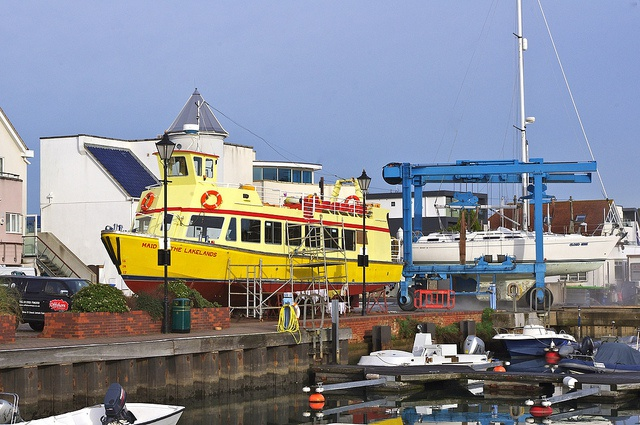Describe the objects in this image and their specific colors. I can see boat in darkgray, khaki, black, and gold tones, boat in darkgray, lightgray, gray, and black tones, boat in darkgray, lightgray, gray, and black tones, car in darkgray, black, and gray tones, and truck in darkgray, black, and gray tones in this image. 